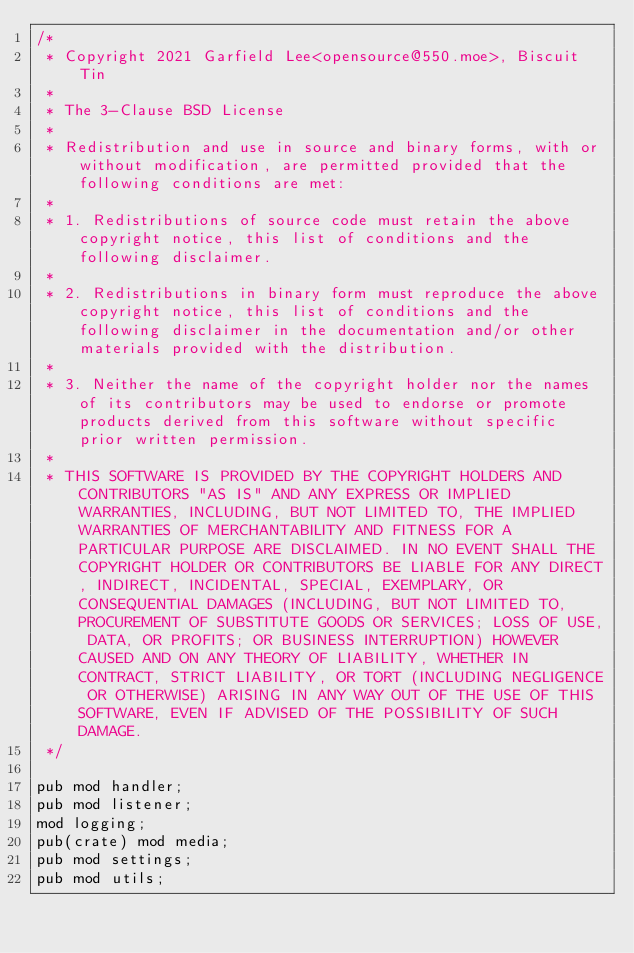<code> <loc_0><loc_0><loc_500><loc_500><_Rust_>/*
 * Copyright 2021 Garfield Lee<opensource@550.moe>, Biscuit Tin
 *
 * The 3-Clause BSD License
 *
 * Redistribution and use in source and binary forms, with or without modification, are permitted provided that the following conditions are met:
 *
 * 1. Redistributions of source code must retain the above copyright notice, this list of conditions and the following disclaimer.
 *
 * 2. Redistributions in binary form must reproduce the above copyright notice, this list of conditions and the following disclaimer in the documentation and/or other materials provided with the distribution.
 *
 * 3. Neither the name of the copyright holder nor the names of its contributors may be used to endorse or promote products derived from this software without specific prior written permission.
 *
 * THIS SOFTWARE IS PROVIDED BY THE COPYRIGHT HOLDERS AND CONTRIBUTORS "AS IS" AND ANY EXPRESS OR IMPLIED WARRANTIES, INCLUDING, BUT NOT LIMITED TO, THE IMPLIED WARRANTIES OF MERCHANTABILITY AND FITNESS FOR A PARTICULAR PURPOSE ARE DISCLAIMED. IN NO EVENT SHALL THE COPYRIGHT HOLDER OR CONTRIBUTORS BE LIABLE FOR ANY DIRECT, INDIRECT, INCIDENTAL, SPECIAL, EXEMPLARY, OR CONSEQUENTIAL DAMAGES (INCLUDING, BUT NOT LIMITED TO, PROCUREMENT OF SUBSTITUTE GOODS OR SERVICES; LOSS OF USE, DATA, OR PROFITS; OR BUSINESS INTERRUPTION) HOWEVER CAUSED AND ON ANY THEORY OF LIABILITY, WHETHER IN CONTRACT, STRICT LIABILITY, OR TORT (INCLUDING NEGLIGENCE OR OTHERWISE) ARISING IN ANY WAY OUT OF THE USE OF THIS SOFTWARE, EVEN IF ADVISED OF THE POSSIBILITY OF SUCH DAMAGE.
 */

pub mod handler;
pub mod listener;
mod logging;
pub(crate) mod media;
pub mod settings;
pub mod utils;
</code> 